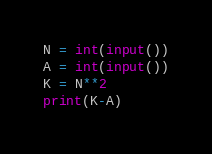Convert code to text. <code><loc_0><loc_0><loc_500><loc_500><_Python_>N = int(input())
A = int(input())
K = N**2
print(K-A)</code> 